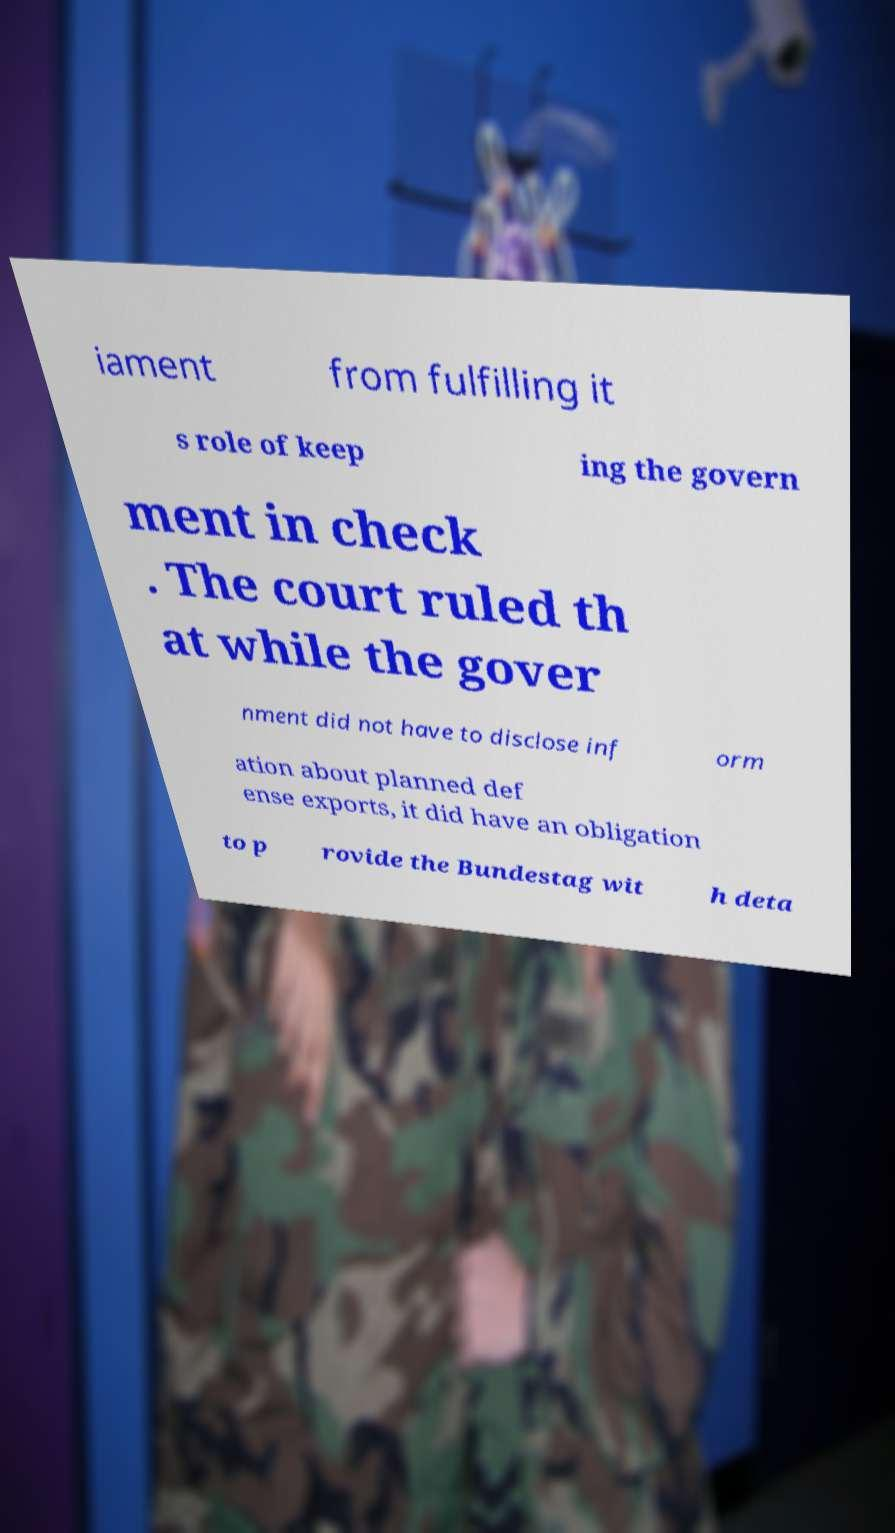Could you extract and type out the text from this image? iament from fulfilling it s role of keep ing the govern ment in check . The court ruled th at while the gover nment did not have to disclose inf orm ation about planned def ense exports, it did have an obligation to p rovide the Bundestag wit h deta 